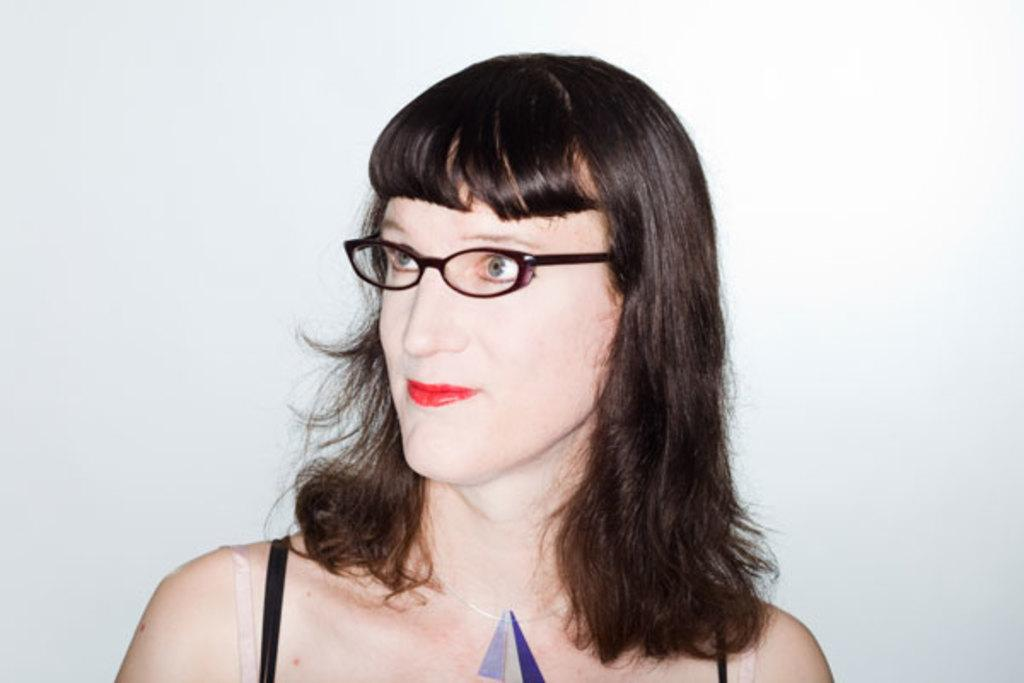Who is the main subject in the image? There is a woman in the image. What is the woman wearing? The woman is wearing a black dress and black-colored spectacles. What is the color of the background in the image? The background of the image is white. Can you tell me how the woman is preparing for the rainstorm in the image? There is no rainstorm present in the image, and the woman's clothing and accessories do not suggest any preparation for rain. 